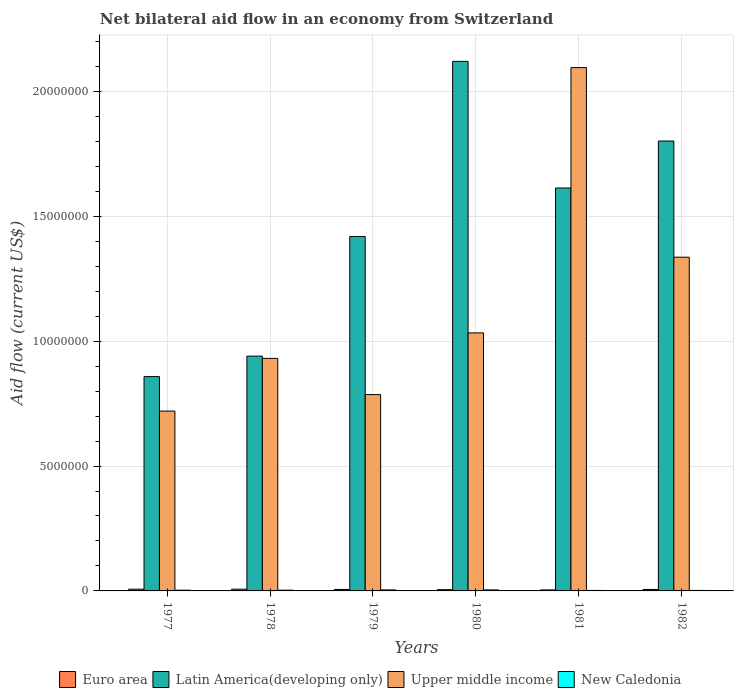How many groups of bars are there?
Your answer should be very brief. 6. How many bars are there on the 3rd tick from the right?
Your response must be concise. 4. In how many cases, is the number of bars for a given year not equal to the number of legend labels?
Your answer should be compact. 0. In which year was the net bilateral aid flow in Upper middle income minimum?
Your answer should be very brief. 1977. What is the total net bilateral aid flow in Euro area in the graph?
Give a very brief answer. 3.50e+05. What is the difference between the net bilateral aid flow in New Caledonia in 1977 and that in 1981?
Offer a terse response. 10000. What is the difference between the net bilateral aid flow in Upper middle income in 1978 and the net bilateral aid flow in Latin America(developing only) in 1980?
Ensure brevity in your answer.  -1.19e+07. What is the average net bilateral aid flow in New Caledonia per year?
Give a very brief answer. 3.00e+04. In the year 1978, what is the difference between the net bilateral aid flow in Upper middle income and net bilateral aid flow in Euro area?
Give a very brief answer. 9.24e+06. What is the ratio of the net bilateral aid flow in Upper middle income in 1979 to that in 1981?
Ensure brevity in your answer.  0.38. Is the difference between the net bilateral aid flow in Upper middle income in 1978 and 1979 greater than the difference between the net bilateral aid flow in Euro area in 1978 and 1979?
Offer a terse response. Yes. What is the difference between the highest and the second highest net bilateral aid flow in Upper middle income?
Offer a very short reply. 7.59e+06. What is the difference between the highest and the lowest net bilateral aid flow in Upper middle income?
Your answer should be compact. 1.38e+07. In how many years, is the net bilateral aid flow in Upper middle income greater than the average net bilateral aid flow in Upper middle income taken over all years?
Ensure brevity in your answer.  2. What does the 4th bar from the left in 1980 represents?
Give a very brief answer. New Caledonia. What does the 1st bar from the right in 1979 represents?
Offer a very short reply. New Caledonia. Is it the case that in every year, the sum of the net bilateral aid flow in New Caledonia and net bilateral aid flow in Euro area is greater than the net bilateral aid flow in Latin America(developing only)?
Your response must be concise. No. Are all the bars in the graph horizontal?
Your answer should be compact. No. How many years are there in the graph?
Offer a terse response. 6. What is the difference between two consecutive major ticks on the Y-axis?
Make the answer very short. 5.00e+06. Does the graph contain any zero values?
Keep it short and to the point. No. Where does the legend appear in the graph?
Provide a succinct answer. Bottom center. How many legend labels are there?
Your answer should be very brief. 4. What is the title of the graph?
Your answer should be compact. Net bilateral aid flow in an economy from Switzerland. What is the label or title of the X-axis?
Your answer should be compact. Years. What is the label or title of the Y-axis?
Your answer should be compact. Aid flow (current US$). What is the Aid flow (current US$) of Euro area in 1977?
Your response must be concise. 7.00e+04. What is the Aid flow (current US$) in Latin America(developing only) in 1977?
Provide a short and direct response. 8.58e+06. What is the Aid flow (current US$) in Upper middle income in 1977?
Offer a very short reply. 7.20e+06. What is the Aid flow (current US$) in Euro area in 1978?
Your response must be concise. 7.00e+04. What is the Aid flow (current US$) of Latin America(developing only) in 1978?
Provide a succinct answer. 9.40e+06. What is the Aid flow (current US$) in Upper middle income in 1978?
Provide a short and direct response. 9.31e+06. What is the Aid flow (current US$) in Euro area in 1979?
Provide a succinct answer. 6.00e+04. What is the Aid flow (current US$) of Latin America(developing only) in 1979?
Keep it short and to the point. 1.42e+07. What is the Aid flow (current US$) of Upper middle income in 1979?
Offer a terse response. 7.86e+06. What is the Aid flow (current US$) in Latin America(developing only) in 1980?
Ensure brevity in your answer.  2.12e+07. What is the Aid flow (current US$) of Upper middle income in 1980?
Offer a terse response. 1.03e+07. What is the Aid flow (current US$) in Latin America(developing only) in 1981?
Provide a succinct answer. 1.61e+07. What is the Aid flow (current US$) in Upper middle income in 1981?
Offer a very short reply. 2.10e+07. What is the Aid flow (current US$) in Euro area in 1982?
Your answer should be very brief. 6.00e+04. What is the Aid flow (current US$) in Latin America(developing only) in 1982?
Provide a short and direct response. 1.80e+07. What is the Aid flow (current US$) in Upper middle income in 1982?
Your answer should be very brief. 1.34e+07. Across all years, what is the maximum Aid flow (current US$) of Latin America(developing only)?
Give a very brief answer. 2.12e+07. Across all years, what is the maximum Aid flow (current US$) in Upper middle income?
Your answer should be very brief. 2.10e+07. Across all years, what is the maximum Aid flow (current US$) of New Caledonia?
Give a very brief answer. 4.00e+04. Across all years, what is the minimum Aid flow (current US$) of Euro area?
Provide a short and direct response. 4.00e+04. Across all years, what is the minimum Aid flow (current US$) of Latin America(developing only)?
Offer a terse response. 8.58e+06. Across all years, what is the minimum Aid flow (current US$) of Upper middle income?
Your response must be concise. 7.20e+06. What is the total Aid flow (current US$) of Latin America(developing only) in the graph?
Keep it short and to the point. 8.75e+07. What is the total Aid flow (current US$) of Upper middle income in the graph?
Offer a very short reply. 6.90e+07. What is the difference between the Aid flow (current US$) in Latin America(developing only) in 1977 and that in 1978?
Provide a short and direct response. -8.20e+05. What is the difference between the Aid flow (current US$) in Upper middle income in 1977 and that in 1978?
Your answer should be compact. -2.11e+06. What is the difference between the Aid flow (current US$) of Latin America(developing only) in 1977 and that in 1979?
Offer a very short reply. -5.61e+06. What is the difference between the Aid flow (current US$) in Upper middle income in 1977 and that in 1979?
Offer a terse response. -6.60e+05. What is the difference between the Aid flow (current US$) in New Caledonia in 1977 and that in 1979?
Offer a very short reply. -10000. What is the difference between the Aid flow (current US$) of Euro area in 1977 and that in 1980?
Provide a short and direct response. 2.00e+04. What is the difference between the Aid flow (current US$) in Latin America(developing only) in 1977 and that in 1980?
Offer a terse response. -1.26e+07. What is the difference between the Aid flow (current US$) of Upper middle income in 1977 and that in 1980?
Provide a succinct answer. -3.13e+06. What is the difference between the Aid flow (current US$) of Latin America(developing only) in 1977 and that in 1981?
Ensure brevity in your answer.  -7.55e+06. What is the difference between the Aid flow (current US$) in Upper middle income in 1977 and that in 1981?
Provide a succinct answer. -1.38e+07. What is the difference between the Aid flow (current US$) in New Caledonia in 1977 and that in 1981?
Your response must be concise. 10000. What is the difference between the Aid flow (current US$) in Latin America(developing only) in 1977 and that in 1982?
Make the answer very short. -9.43e+06. What is the difference between the Aid flow (current US$) of Upper middle income in 1977 and that in 1982?
Your answer should be very brief. -6.16e+06. What is the difference between the Aid flow (current US$) in Latin America(developing only) in 1978 and that in 1979?
Ensure brevity in your answer.  -4.79e+06. What is the difference between the Aid flow (current US$) in Upper middle income in 1978 and that in 1979?
Provide a short and direct response. 1.45e+06. What is the difference between the Aid flow (current US$) in Euro area in 1978 and that in 1980?
Offer a very short reply. 2.00e+04. What is the difference between the Aid flow (current US$) of Latin America(developing only) in 1978 and that in 1980?
Your response must be concise. -1.18e+07. What is the difference between the Aid flow (current US$) in Upper middle income in 1978 and that in 1980?
Your response must be concise. -1.02e+06. What is the difference between the Aid flow (current US$) of Latin America(developing only) in 1978 and that in 1981?
Make the answer very short. -6.73e+06. What is the difference between the Aid flow (current US$) in Upper middle income in 1978 and that in 1981?
Keep it short and to the point. -1.16e+07. What is the difference between the Aid flow (current US$) in Latin America(developing only) in 1978 and that in 1982?
Provide a short and direct response. -8.61e+06. What is the difference between the Aid flow (current US$) of Upper middle income in 1978 and that in 1982?
Keep it short and to the point. -4.05e+06. What is the difference between the Aid flow (current US$) of Euro area in 1979 and that in 1980?
Give a very brief answer. 10000. What is the difference between the Aid flow (current US$) in Latin America(developing only) in 1979 and that in 1980?
Provide a succinct answer. -7.01e+06. What is the difference between the Aid flow (current US$) of Upper middle income in 1979 and that in 1980?
Offer a very short reply. -2.47e+06. What is the difference between the Aid flow (current US$) of Euro area in 1979 and that in 1981?
Offer a very short reply. 2.00e+04. What is the difference between the Aid flow (current US$) of Latin America(developing only) in 1979 and that in 1981?
Your response must be concise. -1.94e+06. What is the difference between the Aid flow (current US$) of Upper middle income in 1979 and that in 1981?
Provide a succinct answer. -1.31e+07. What is the difference between the Aid flow (current US$) of Euro area in 1979 and that in 1982?
Provide a succinct answer. 0. What is the difference between the Aid flow (current US$) in Latin America(developing only) in 1979 and that in 1982?
Your answer should be compact. -3.82e+06. What is the difference between the Aid flow (current US$) of Upper middle income in 1979 and that in 1982?
Your answer should be compact. -5.50e+06. What is the difference between the Aid flow (current US$) in New Caledonia in 1979 and that in 1982?
Make the answer very short. 2.00e+04. What is the difference between the Aid flow (current US$) of Euro area in 1980 and that in 1981?
Your response must be concise. 10000. What is the difference between the Aid flow (current US$) in Latin America(developing only) in 1980 and that in 1981?
Your response must be concise. 5.07e+06. What is the difference between the Aid flow (current US$) in Upper middle income in 1980 and that in 1981?
Offer a very short reply. -1.06e+07. What is the difference between the Aid flow (current US$) of New Caledonia in 1980 and that in 1981?
Ensure brevity in your answer.  2.00e+04. What is the difference between the Aid flow (current US$) of Euro area in 1980 and that in 1982?
Give a very brief answer. -10000. What is the difference between the Aid flow (current US$) of Latin America(developing only) in 1980 and that in 1982?
Keep it short and to the point. 3.19e+06. What is the difference between the Aid flow (current US$) of Upper middle income in 1980 and that in 1982?
Your answer should be compact. -3.03e+06. What is the difference between the Aid flow (current US$) in New Caledonia in 1980 and that in 1982?
Your answer should be compact. 2.00e+04. What is the difference between the Aid flow (current US$) of Euro area in 1981 and that in 1982?
Keep it short and to the point. -2.00e+04. What is the difference between the Aid flow (current US$) in Latin America(developing only) in 1981 and that in 1982?
Provide a succinct answer. -1.88e+06. What is the difference between the Aid flow (current US$) of Upper middle income in 1981 and that in 1982?
Provide a succinct answer. 7.59e+06. What is the difference between the Aid flow (current US$) in Euro area in 1977 and the Aid flow (current US$) in Latin America(developing only) in 1978?
Offer a very short reply. -9.33e+06. What is the difference between the Aid flow (current US$) of Euro area in 1977 and the Aid flow (current US$) of Upper middle income in 1978?
Make the answer very short. -9.24e+06. What is the difference between the Aid flow (current US$) in Euro area in 1977 and the Aid flow (current US$) in New Caledonia in 1978?
Your answer should be compact. 4.00e+04. What is the difference between the Aid flow (current US$) in Latin America(developing only) in 1977 and the Aid flow (current US$) in Upper middle income in 1978?
Your answer should be compact. -7.30e+05. What is the difference between the Aid flow (current US$) in Latin America(developing only) in 1977 and the Aid flow (current US$) in New Caledonia in 1978?
Offer a very short reply. 8.55e+06. What is the difference between the Aid flow (current US$) in Upper middle income in 1977 and the Aid flow (current US$) in New Caledonia in 1978?
Provide a short and direct response. 7.17e+06. What is the difference between the Aid flow (current US$) of Euro area in 1977 and the Aid flow (current US$) of Latin America(developing only) in 1979?
Provide a short and direct response. -1.41e+07. What is the difference between the Aid flow (current US$) of Euro area in 1977 and the Aid flow (current US$) of Upper middle income in 1979?
Your answer should be very brief. -7.79e+06. What is the difference between the Aid flow (current US$) in Euro area in 1977 and the Aid flow (current US$) in New Caledonia in 1979?
Your answer should be compact. 3.00e+04. What is the difference between the Aid flow (current US$) of Latin America(developing only) in 1977 and the Aid flow (current US$) of Upper middle income in 1979?
Keep it short and to the point. 7.20e+05. What is the difference between the Aid flow (current US$) in Latin America(developing only) in 1977 and the Aid flow (current US$) in New Caledonia in 1979?
Provide a succinct answer. 8.54e+06. What is the difference between the Aid flow (current US$) of Upper middle income in 1977 and the Aid flow (current US$) of New Caledonia in 1979?
Give a very brief answer. 7.16e+06. What is the difference between the Aid flow (current US$) of Euro area in 1977 and the Aid flow (current US$) of Latin America(developing only) in 1980?
Offer a very short reply. -2.11e+07. What is the difference between the Aid flow (current US$) of Euro area in 1977 and the Aid flow (current US$) of Upper middle income in 1980?
Your answer should be very brief. -1.03e+07. What is the difference between the Aid flow (current US$) in Latin America(developing only) in 1977 and the Aid flow (current US$) in Upper middle income in 1980?
Your answer should be very brief. -1.75e+06. What is the difference between the Aid flow (current US$) in Latin America(developing only) in 1977 and the Aid flow (current US$) in New Caledonia in 1980?
Keep it short and to the point. 8.54e+06. What is the difference between the Aid flow (current US$) in Upper middle income in 1977 and the Aid flow (current US$) in New Caledonia in 1980?
Your response must be concise. 7.16e+06. What is the difference between the Aid flow (current US$) of Euro area in 1977 and the Aid flow (current US$) of Latin America(developing only) in 1981?
Ensure brevity in your answer.  -1.61e+07. What is the difference between the Aid flow (current US$) in Euro area in 1977 and the Aid flow (current US$) in Upper middle income in 1981?
Your answer should be compact. -2.09e+07. What is the difference between the Aid flow (current US$) of Latin America(developing only) in 1977 and the Aid flow (current US$) of Upper middle income in 1981?
Your response must be concise. -1.24e+07. What is the difference between the Aid flow (current US$) of Latin America(developing only) in 1977 and the Aid flow (current US$) of New Caledonia in 1981?
Offer a very short reply. 8.56e+06. What is the difference between the Aid flow (current US$) in Upper middle income in 1977 and the Aid flow (current US$) in New Caledonia in 1981?
Provide a succinct answer. 7.18e+06. What is the difference between the Aid flow (current US$) in Euro area in 1977 and the Aid flow (current US$) in Latin America(developing only) in 1982?
Your answer should be very brief. -1.79e+07. What is the difference between the Aid flow (current US$) of Euro area in 1977 and the Aid flow (current US$) of Upper middle income in 1982?
Offer a terse response. -1.33e+07. What is the difference between the Aid flow (current US$) in Latin America(developing only) in 1977 and the Aid flow (current US$) in Upper middle income in 1982?
Provide a short and direct response. -4.78e+06. What is the difference between the Aid flow (current US$) of Latin America(developing only) in 1977 and the Aid flow (current US$) of New Caledonia in 1982?
Provide a short and direct response. 8.56e+06. What is the difference between the Aid flow (current US$) of Upper middle income in 1977 and the Aid flow (current US$) of New Caledonia in 1982?
Give a very brief answer. 7.18e+06. What is the difference between the Aid flow (current US$) of Euro area in 1978 and the Aid flow (current US$) of Latin America(developing only) in 1979?
Your response must be concise. -1.41e+07. What is the difference between the Aid flow (current US$) in Euro area in 1978 and the Aid flow (current US$) in Upper middle income in 1979?
Provide a short and direct response. -7.79e+06. What is the difference between the Aid flow (current US$) of Euro area in 1978 and the Aid flow (current US$) of New Caledonia in 1979?
Give a very brief answer. 3.00e+04. What is the difference between the Aid flow (current US$) in Latin America(developing only) in 1978 and the Aid flow (current US$) in Upper middle income in 1979?
Provide a succinct answer. 1.54e+06. What is the difference between the Aid flow (current US$) of Latin America(developing only) in 1978 and the Aid flow (current US$) of New Caledonia in 1979?
Provide a short and direct response. 9.36e+06. What is the difference between the Aid flow (current US$) of Upper middle income in 1978 and the Aid flow (current US$) of New Caledonia in 1979?
Ensure brevity in your answer.  9.27e+06. What is the difference between the Aid flow (current US$) of Euro area in 1978 and the Aid flow (current US$) of Latin America(developing only) in 1980?
Provide a succinct answer. -2.11e+07. What is the difference between the Aid flow (current US$) of Euro area in 1978 and the Aid flow (current US$) of Upper middle income in 1980?
Make the answer very short. -1.03e+07. What is the difference between the Aid flow (current US$) in Latin America(developing only) in 1978 and the Aid flow (current US$) in Upper middle income in 1980?
Make the answer very short. -9.30e+05. What is the difference between the Aid flow (current US$) in Latin America(developing only) in 1978 and the Aid flow (current US$) in New Caledonia in 1980?
Offer a terse response. 9.36e+06. What is the difference between the Aid flow (current US$) in Upper middle income in 1978 and the Aid flow (current US$) in New Caledonia in 1980?
Your answer should be compact. 9.27e+06. What is the difference between the Aid flow (current US$) in Euro area in 1978 and the Aid flow (current US$) in Latin America(developing only) in 1981?
Your answer should be very brief. -1.61e+07. What is the difference between the Aid flow (current US$) in Euro area in 1978 and the Aid flow (current US$) in Upper middle income in 1981?
Your answer should be very brief. -2.09e+07. What is the difference between the Aid flow (current US$) of Latin America(developing only) in 1978 and the Aid flow (current US$) of Upper middle income in 1981?
Ensure brevity in your answer.  -1.16e+07. What is the difference between the Aid flow (current US$) of Latin America(developing only) in 1978 and the Aid flow (current US$) of New Caledonia in 1981?
Give a very brief answer. 9.38e+06. What is the difference between the Aid flow (current US$) of Upper middle income in 1978 and the Aid flow (current US$) of New Caledonia in 1981?
Give a very brief answer. 9.29e+06. What is the difference between the Aid flow (current US$) of Euro area in 1978 and the Aid flow (current US$) of Latin America(developing only) in 1982?
Make the answer very short. -1.79e+07. What is the difference between the Aid flow (current US$) of Euro area in 1978 and the Aid flow (current US$) of Upper middle income in 1982?
Make the answer very short. -1.33e+07. What is the difference between the Aid flow (current US$) of Euro area in 1978 and the Aid flow (current US$) of New Caledonia in 1982?
Give a very brief answer. 5.00e+04. What is the difference between the Aid flow (current US$) of Latin America(developing only) in 1978 and the Aid flow (current US$) of Upper middle income in 1982?
Make the answer very short. -3.96e+06. What is the difference between the Aid flow (current US$) of Latin America(developing only) in 1978 and the Aid flow (current US$) of New Caledonia in 1982?
Provide a succinct answer. 9.38e+06. What is the difference between the Aid flow (current US$) in Upper middle income in 1978 and the Aid flow (current US$) in New Caledonia in 1982?
Your answer should be compact. 9.29e+06. What is the difference between the Aid flow (current US$) in Euro area in 1979 and the Aid flow (current US$) in Latin America(developing only) in 1980?
Keep it short and to the point. -2.11e+07. What is the difference between the Aid flow (current US$) of Euro area in 1979 and the Aid flow (current US$) of Upper middle income in 1980?
Your answer should be very brief. -1.03e+07. What is the difference between the Aid flow (current US$) in Latin America(developing only) in 1979 and the Aid flow (current US$) in Upper middle income in 1980?
Your answer should be very brief. 3.86e+06. What is the difference between the Aid flow (current US$) of Latin America(developing only) in 1979 and the Aid flow (current US$) of New Caledonia in 1980?
Your response must be concise. 1.42e+07. What is the difference between the Aid flow (current US$) of Upper middle income in 1979 and the Aid flow (current US$) of New Caledonia in 1980?
Provide a short and direct response. 7.82e+06. What is the difference between the Aid flow (current US$) in Euro area in 1979 and the Aid flow (current US$) in Latin America(developing only) in 1981?
Your response must be concise. -1.61e+07. What is the difference between the Aid flow (current US$) in Euro area in 1979 and the Aid flow (current US$) in Upper middle income in 1981?
Provide a short and direct response. -2.09e+07. What is the difference between the Aid flow (current US$) in Latin America(developing only) in 1979 and the Aid flow (current US$) in Upper middle income in 1981?
Offer a terse response. -6.76e+06. What is the difference between the Aid flow (current US$) in Latin America(developing only) in 1979 and the Aid flow (current US$) in New Caledonia in 1981?
Your response must be concise. 1.42e+07. What is the difference between the Aid flow (current US$) in Upper middle income in 1979 and the Aid flow (current US$) in New Caledonia in 1981?
Your answer should be very brief. 7.84e+06. What is the difference between the Aid flow (current US$) in Euro area in 1979 and the Aid flow (current US$) in Latin America(developing only) in 1982?
Give a very brief answer. -1.80e+07. What is the difference between the Aid flow (current US$) in Euro area in 1979 and the Aid flow (current US$) in Upper middle income in 1982?
Offer a very short reply. -1.33e+07. What is the difference between the Aid flow (current US$) in Euro area in 1979 and the Aid flow (current US$) in New Caledonia in 1982?
Make the answer very short. 4.00e+04. What is the difference between the Aid flow (current US$) of Latin America(developing only) in 1979 and the Aid flow (current US$) of Upper middle income in 1982?
Offer a terse response. 8.30e+05. What is the difference between the Aid flow (current US$) in Latin America(developing only) in 1979 and the Aid flow (current US$) in New Caledonia in 1982?
Provide a short and direct response. 1.42e+07. What is the difference between the Aid flow (current US$) in Upper middle income in 1979 and the Aid flow (current US$) in New Caledonia in 1982?
Your answer should be very brief. 7.84e+06. What is the difference between the Aid flow (current US$) of Euro area in 1980 and the Aid flow (current US$) of Latin America(developing only) in 1981?
Give a very brief answer. -1.61e+07. What is the difference between the Aid flow (current US$) of Euro area in 1980 and the Aid flow (current US$) of Upper middle income in 1981?
Offer a terse response. -2.09e+07. What is the difference between the Aid flow (current US$) in Euro area in 1980 and the Aid flow (current US$) in New Caledonia in 1981?
Your answer should be very brief. 3.00e+04. What is the difference between the Aid flow (current US$) of Latin America(developing only) in 1980 and the Aid flow (current US$) of Upper middle income in 1981?
Provide a succinct answer. 2.50e+05. What is the difference between the Aid flow (current US$) of Latin America(developing only) in 1980 and the Aid flow (current US$) of New Caledonia in 1981?
Your answer should be compact. 2.12e+07. What is the difference between the Aid flow (current US$) in Upper middle income in 1980 and the Aid flow (current US$) in New Caledonia in 1981?
Offer a terse response. 1.03e+07. What is the difference between the Aid flow (current US$) in Euro area in 1980 and the Aid flow (current US$) in Latin America(developing only) in 1982?
Offer a very short reply. -1.80e+07. What is the difference between the Aid flow (current US$) in Euro area in 1980 and the Aid flow (current US$) in Upper middle income in 1982?
Make the answer very short. -1.33e+07. What is the difference between the Aid flow (current US$) of Euro area in 1980 and the Aid flow (current US$) of New Caledonia in 1982?
Keep it short and to the point. 3.00e+04. What is the difference between the Aid flow (current US$) of Latin America(developing only) in 1980 and the Aid flow (current US$) of Upper middle income in 1982?
Offer a terse response. 7.84e+06. What is the difference between the Aid flow (current US$) in Latin America(developing only) in 1980 and the Aid flow (current US$) in New Caledonia in 1982?
Your answer should be very brief. 2.12e+07. What is the difference between the Aid flow (current US$) of Upper middle income in 1980 and the Aid flow (current US$) of New Caledonia in 1982?
Ensure brevity in your answer.  1.03e+07. What is the difference between the Aid flow (current US$) of Euro area in 1981 and the Aid flow (current US$) of Latin America(developing only) in 1982?
Offer a terse response. -1.80e+07. What is the difference between the Aid flow (current US$) of Euro area in 1981 and the Aid flow (current US$) of Upper middle income in 1982?
Provide a short and direct response. -1.33e+07. What is the difference between the Aid flow (current US$) in Euro area in 1981 and the Aid flow (current US$) in New Caledonia in 1982?
Keep it short and to the point. 2.00e+04. What is the difference between the Aid flow (current US$) of Latin America(developing only) in 1981 and the Aid flow (current US$) of Upper middle income in 1982?
Your response must be concise. 2.77e+06. What is the difference between the Aid flow (current US$) in Latin America(developing only) in 1981 and the Aid flow (current US$) in New Caledonia in 1982?
Ensure brevity in your answer.  1.61e+07. What is the difference between the Aid flow (current US$) in Upper middle income in 1981 and the Aid flow (current US$) in New Caledonia in 1982?
Your answer should be compact. 2.09e+07. What is the average Aid flow (current US$) of Euro area per year?
Provide a short and direct response. 5.83e+04. What is the average Aid flow (current US$) of Latin America(developing only) per year?
Keep it short and to the point. 1.46e+07. What is the average Aid flow (current US$) of Upper middle income per year?
Your response must be concise. 1.15e+07. What is the average Aid flow (current US$) of New Caledonia per year?
Offer a very short reply. 3.00e+04. In the year 1977, what is the difference between the Aid flow (current US$) of Euro area and Aid flow (current US$) of Latin America(developing only)?
Make the answer very short. -8.51e+06. In the year 1977, what is the difference between the Aid flow (current US$) of Euro area and Aid flow (current US$) of Upper middle income?
Provide a short and direct response. -7.13e+06. In the year 1977, what is the difference between the Aid flow (current US$) in Latin America(developing only) and Aid flow (current US$) in Upper middle income?
Provide a short and direct response. 1.38e+06. In the year 1977, what is the difference between the Aid flow (current US$) of Latin America(developing only) and Aid flow (current US$) of New Caledonia?
Offer a terse response. 8.55e+06. In the year 1977, what is the difference between the Aid flow (current US$) of Upper middle income and Aid flow (current US$) of New Caledonia?
Give a very brief answer. 7.17e+06. In the year 1978, what is the difference between the Aid flow (current US$) of Euro area and Aid flow (current US$) of Latin America(developing only)?
Give a very brief answer. -9.33e+06. In the year 1978, what is the difference between the Aid flow (current US$) of Euro area and Aid flow (current US$) of Upper middle income?
Make the answer very short. -9.24e+06. In the year 1978, what is the difference between the Aid flow (current US$) of Euro area and Aid flow (current US$) of New Caledonia?
Provide a succinct answer. 4.00e+04. In the year 1978, what is the difference between the Aid flow (current US$) in Latin America(developing only) and Aid flow (current US$) in New Caledonia?
Your answer should be very brief. 9.37e+06. In the year 1978, what is the difference between the Aid flow (current US$) of Upper middle income and Aid flow (current US$) of New Caledonia?
Your answer should be very brief. 9.28e+06. In the year 1979, what is the difference between the Aid flow (current US$) in Euro area and Aid flow (current US$) in Latin America(developing only)?
Your answer should be very brief. -1.41e+07. In the year 1979, what is the difference between the Aid flow (current US$) of Euro area and Aid flow (current US$) of Upper middle income?
Keep it short and to the point. -7.80e+06. In the year 1979, what is the difference between the Aid flow (current US$) in Euro area and Aid flow (current US$) in New Caledonia?
Give a very brief answer. 2.00e+04. In the year 1979, what is the difference between the Aid flow (current US$) of Latin America(developing only) and Aid flow (current US$) of Upper middle income?
Your answer should be compact. 6.33e+06. In the year 1979, what is the difference between the Aid flow (current US$) in Latin America(developing only) and Aid flow (current US$) in New Caledonia?
Give a very brief answer. 1.42e+07. In the year 1979, what is the difference between the Aid flow (current US$) of Upper middle income and Aid flow (current US$) of New Caledonia?
Ensure brevity in your answer.  7.82e+06. In the year 1980, what is the difference between the Aid flow (current US$) in Euro area and Aid flow (current US$) in Latin America(developing only)?
Make the answer very short. -2.12e+07. In the year 1980, what is the difference between the Aid flow (current US$) of Euro area and Aid flow (current US$) of Upper middle income?
Offer a very short reply. -1.03e+07. In the year 1980, what is the difference between the Aid flow (current US$) in Euro area and Aid flow (current US$) in New Caledonia?
Keep it short and to the point. 10000. In the year 1980, what is the difference between the Aid flow (current US$) of Latin America(developing only) and Aid flow (current US$) of Upper middle income?
Give a very brief answer. 1.09e+07. In the year 1980, what is the difference between the Aid flow (current US$) in Latin America(developing only) and Aid flow (current US$) in New Caledonia?
Your response must be concise. 2.12e+07. In the year 1980, what is the difference between the Aid flow (current US$) of Upper middle income and Aid flow (current US$) of New Caledonia?
Provide a succinct answer. 1.03e+07. In the year 1981, what is the difference between the Aid flow (current US$) of Euro area and Aid flow (current US$) of Latin America(developing only)?
Your response must be concise. -1.61e+07. In the year 1981, what is the difference between the Aid flow (current US$) in Euro area and Aid flow (current US$) in Upper middle income?
Your answer should be very brief. -2.09e+07. In the year 1981, what is the difference between the Aid flow (current US$) of Euro area and Aid flow (current US$) of New Caledonia?
Offer a very short reply. 2.00e+04. In the year 1981, what is the difference between the Aid flow (current US$) of Latin America(developing only) and Aid flow (current US$) of Upper middle income?
Your answer should be very brief. -4.82e+06. In the year 1981, what is the difference between the Aid flow (current US$) of Latin America(developing only) and Aid flow (current US$) of New Caledonia?
Your response must be concise. 1.61e+07. In the year 1981, what is the difference between the Aid flow (current US$) of Upper middle income and Aid flow (current US$) of New Caledonia?
Your answer should be very brief. 2.09e+07. In the year 1982, what is the difference between the Aid flow (current US$) of Euro area and Aid flow (current US$) of Latin America(developing only)?
Make the answer very short. -1.80e+07. In the year 1982, what is the difference between the Aid flow (current US$) of Euro area and Aid flow (current US$) of Upper middle income?
Provide a short and direct response. -1.33e+07. In the year 1982, what is the difference between the Aid flow (current US$) in Euro area and Aid flow (current US$) in New Caledonia?
Give a very brief answer. 4.00e+04. In the year 1982, what is the difference between the Aid flow (current US$) of Latin America(developing only) and Aid flow (current US$) of Upper middle income?
Keep it short and to the point. 4.65e+06. In the year 1982, what is the difference between the Aid flow (current US$) in Latin America(developing only) and Aid flow (current US$) in New Caledonia?
Give a very brief answer. 1.80e+07. In the year 1982, what is the difference between the Aid flow (current US$) of Upper middle income and Aid flow (current US$) of New Caledonia?
Your answer should be very brief. 1.33e+07. What is the ratio of the Aid flow (current US$) in Latin America(developing only) in 1977 to that in 1978?
Keep it short and to the point. 0.91. What is the ratio of the Aid flow (current US$) of Upper middle income in 1977 to that in 1978?
Keep it short and to the point. 0.77. What is the ratio of the Aid flow (current US$) of New Caledonia in 1977 to that in 1978?
Offer a very short reply. 1. What is the ratio of the Aid flow (current US$) of Latin America(developing only) in 1977 to that in 1979?
Keep it short and to the point. 0.6. What is the ratio of the Aid flow (current US$) in Upper middle income in 1977 to that in 1979?
Keep it short and to the point. 0.92. What is the ratio of the Aid flow (current US$) of New Caledonia in 1977 to that in 1979?
Ensure brevity in your answer.  0.75. What is the ratio of the Aid flow (current US$) in Latin America(developing only) in 1977 to that in 1980?
Ensure brevity in your answer.  0.4. What is the ratio of the Aid flow (current US$) in Upper middle income in 1977 to that in 1980?
Provide a succinct answer. 0.7. What is the ratio of the Aid flow (current US$) of New Caledonia in 1977 to that in 1980?
Offer a terse response. 0.75. What is the ratio of the Aid flow (current US$) of Latin America(developing only) in 1977 to that in 1981?
Ensure brevity in your answer.  0.53. What is the ratio of the Aid flow (current US$) of Upper middle income in 1977 to that in 1981?
Your answer should be compact. 0.34. What is the ratio of the Aid flow (current US$) in Euro area in 1977 to that in 1982?
Make the answer very short. 1.17. What is the ratio of the Aid flow (current US$) of Latin America(developing only) in 1977 to that in 1982?
Your response must be concise. 0.48. What is the ratio of the Aid flow (current US$) of Upper middle income in 1977 to that in 1982?
Your answer should be compact. 0.54. What is the ratio of the Aid flow (current US$) of Latin America(developing only) in 1978 to that in 1979?
Provide a succinct answer. 0.66. What is the ratio of the Aid flow (current US$) of Upper middle income in 1978 to that in 1979?
Your response must be concise. 1.18. What is the ratio of the Aid flow (current US$) of Euro area in 1978 to that in 1980?
Offer a very short reply. 1.4. What is the ratio of the Aid flow (current US$) in Latin America(developing only) in 1978 to that in 1980?
Your answer should be compact. 0.44. What is the ratio of the Aid flow (current US$) in Upper middle income in 1978 to that in 1980?
Offer a terse response. 0.9. What is the ratio of the Aid flow (current US$) of New Caledonia in 1978 to that in 1980?
Provide a short and direct response. 0.75. What is the ratio of the Aid flow (current US$) in Euro area in 1978 to that in 1981?
Offer a terse response. 1.75. What is the ratio of the Aid flow (current US$) in Latin America(developing only) in 1978 to that in 1981?
Provide a succinct answer. 0.58. What is the ratio of the Aid flow (current US$) of Upper middle income in 1978 to that in 1981?
Your answer should be compact. 0.44. What is the ratio of the Aid flow (current US$) of New Caledonia in 1978 to that in 1981?
Your answer should be compact. 1.5. What is the ratio of the Aid flow (current US$) of Latin America(developing only) in 1978 to that in 1982?
Provide a short and direct response. 0.52. What is the ratio of the Aid flow (current US$) of Upper middle income in 1978 to that in 1982?
Your answer should be compact. 0.7. What is the ratio of the Aid flow (current US$) of New Caledonia in 1978 to that in 1982?
Your response must be concise. 1.5. What is the ratio of the Aid flow (current US$) of Euro area in 1979 to that in 1980?
Ensure brevity in your answer.  1.2. What is the ratio of the Aid flow (current US$) of Latin America(developing only) in 1979 to that in 1980?
Offer a very short reply. 0.67. What is the ratio of the Aid flow (current US$) in Upper middle income in 1979 to that in 1980?
Your answer should be very brief. 0.76. What is the ratio of the Aid flow (current US$) of Euro area in 1979 to that in 1981?
Keep it short and to the point. 1.5. What is the ratio of the Aid flow (current US$) of Latin America(developing only) in 1979 to that in 1981?
Ensure brevity in your answer.  0.88. What is the ratio of the Aid flow (current US$) of Upper middle income in 1979 to that in 1981?
Your answer should be compact. 0.38. What is the ratio of the Aid flow (current US$) in Euro area in 1979 to that in 1982?
Offer a terse response. 1. What is the ratio of the Aid flow (current US$) of Latin America(developing only) in 1979 to that in 1982?
Provide a short and direct response. 0.79. What is the ratio of the Aid flow (current US$) of Upper middle income in 1979 to that in 1982?
Offer a terse response. 0.59. What is the ratio of the Aid flow (current US$) in Euro area in 1980 to that in 1981?
Offer a terse response. 1.25. What is the ratio of the Aid flow (current US$) of Latin America(developing only) in 1980 to that in 1981?
Provide a succinct answer. 1.31. What is the ratio of the Aid flow (current US$) in Upper middle income in 1980 to that in 1981?
Provide a short and direct response. 0.49. What is the ratio of the Aid flow (current US$) of Euro area in 1980 to that in 1982?
Keep it short and to the point. 0.83. What is the ratio of the Aid flow (current US$) of Latin America(developing only) in 1980 to that in 1982?
Make the answer very short. 1.18. What is the ratio of the Aid flow (current US$) in Upper middle income in 1980 to that in 1982?
Offer a very short reply. 0.77. What is the ratio of the Aid flow (current US$) of New Caledonia in 1980 to that in 1982?
Offer a terse response. 2. What is the ratio of the Aid flow (current US$) of Euro area in 1981 to that in 1982?
Provide a short and direct response. 0.67. What is the ratio of the Aid flow (current US$) in Latin America(developing only) in 1981 to that in 1982?
Your answer should be very brief. 0.9. What is the ratio of the Aid flow (current US$) of Upper middle income in 1981 to that in 1982?
Your response must be concise. 1.57. What is the difference between the highest and the second highest Aid flow (current US$) in Latin America(developing only)?
Your response must be concise. 3.19e+06. What is the difference between the highest and the second highest Aid flow (current US$) in Upper middle income?
Give a very brief answer. 7.59e+06. What is the difference between the highest and the second highest Aid flow (current US$) in New Caledonia?
Provide a succinct answer. 0. What is the difference between the highest and the lowest Aid flow (current US$) in Euro area?
Your answer should be very brief. 3.00e+04. What is the difference between the highest and the lowest Aid flow (current US$) of Latin America(developing only)?
Provide a short and direct response. 1.26e+07. What is the difference between the highest and the lowest Aid flow (current US$) in Upper middle income?
Provide a succinct answer. 1.38e+07. 